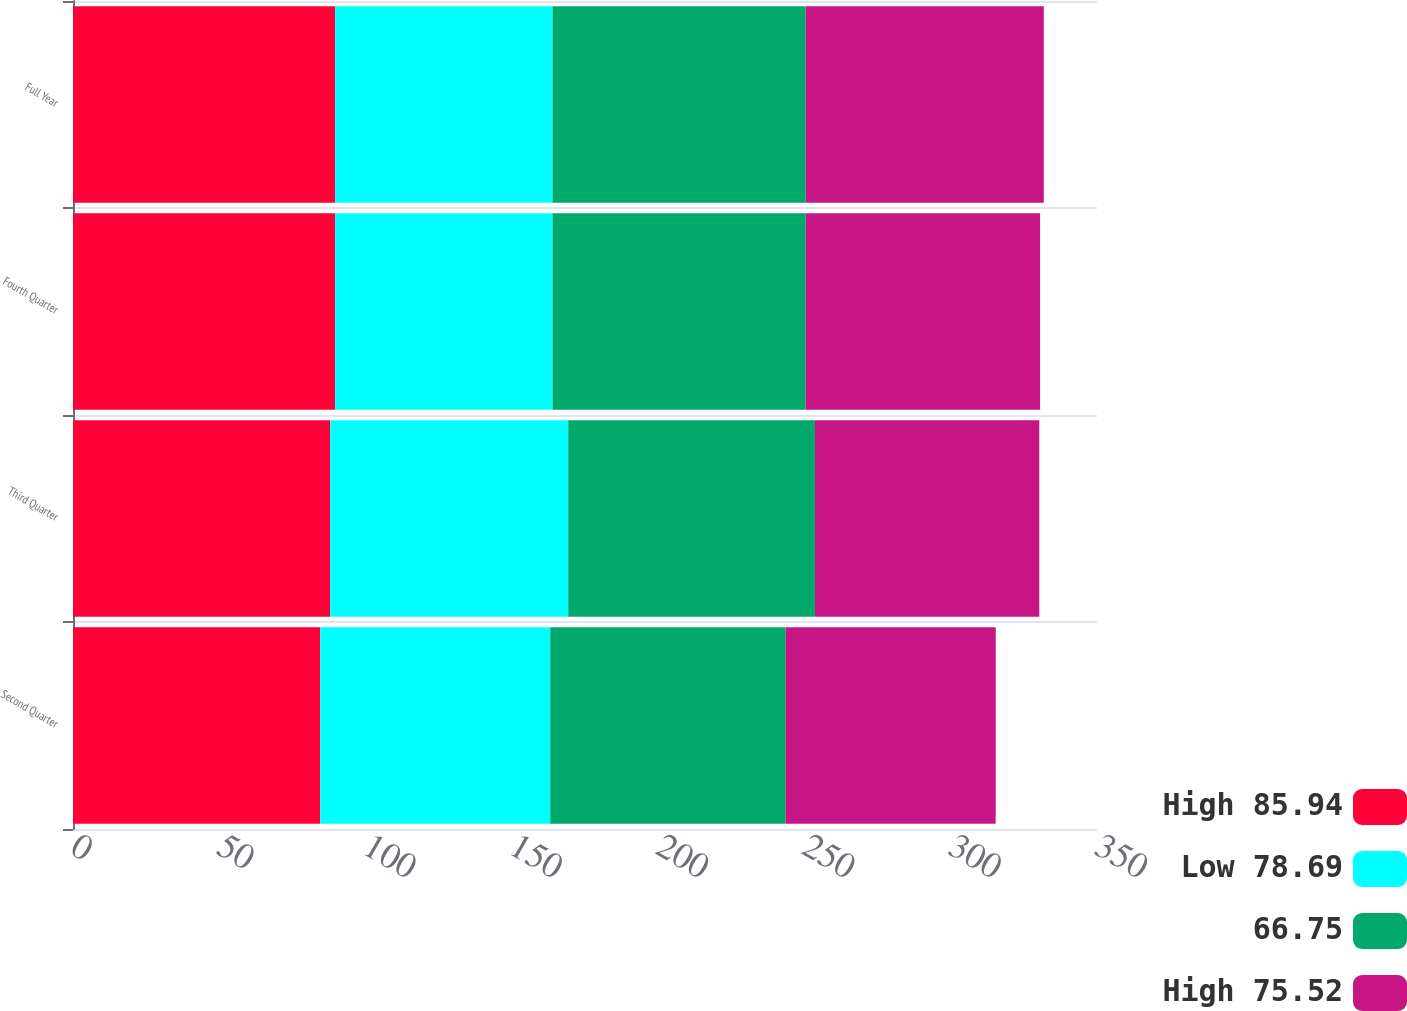Convert chart. <chart><loc_0><loc_0><loc_500><loc_500><stacked_bar_chart><ecel><fcel>Second Quarter<fcel>Third Quarter<fcel>Fourth Quarter<fcel>Full Year<nl><fcel>High 85.94<fcel>84.52<fcel>87.89<fcel>89.59<fcel>89.59<nl><fcel>Low 78.69<fcel>78.6<fcel>81.38<fcel>74.3<fcel>74.3<nl><fcel>66.75<fcel>80.47<fcel>84.32<fcel>86.54<fcel>86.54<nl><fcel>High 75.52<fcel>71.79<fcel>76.68<fcel>80.12<fcel>81.38<nl></chart> 